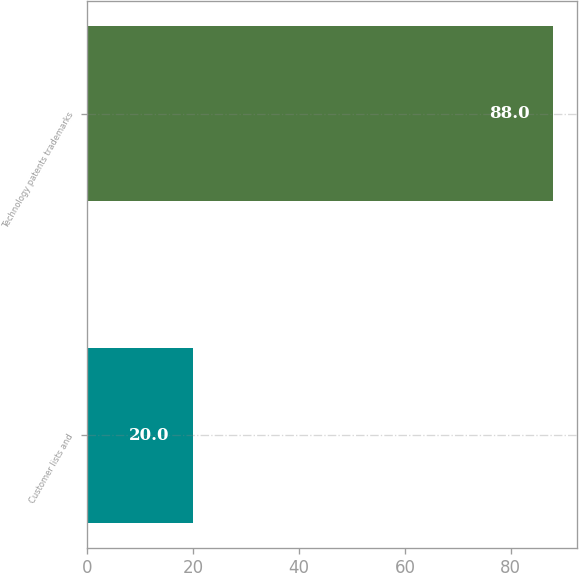Convert chart to OTSL. <chart><loc_0><loc_0><loc_500><loc_500><bar_chart><fcel>Customer lists and<fcel>Technology patents trademarks<nl><fcel>20<fcel>88<nl></chart> 